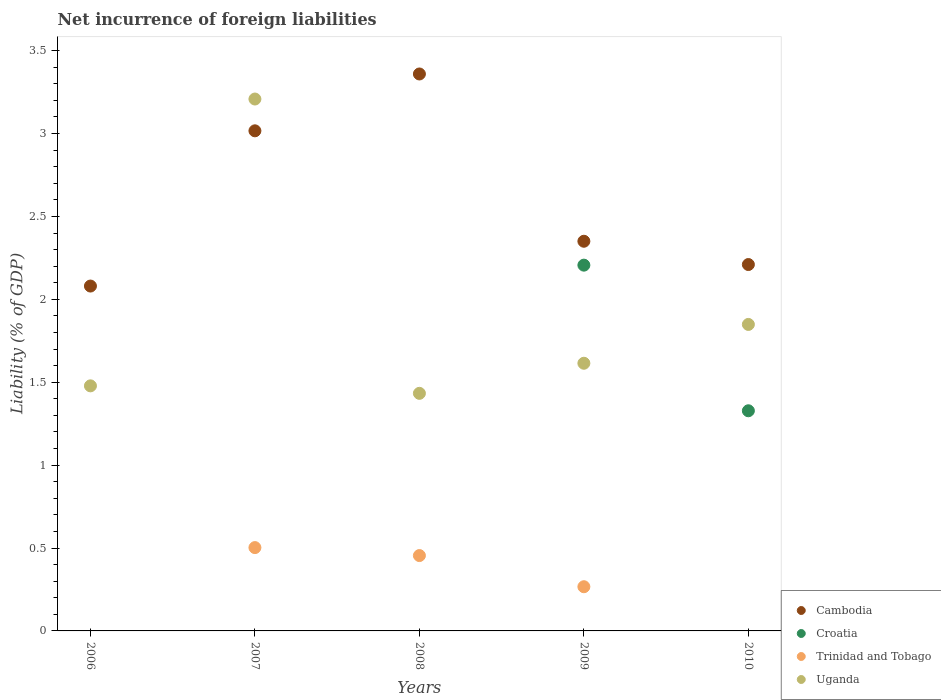What is the net incurrence of foreign liabilities in Cambodia in 2007?
Offer a terse response. 3.02. Across all years, what is the maximum net incurrence of foreign liabilities in Cambodia?
Provide a short and direct response. 3.36. In which year was the net incurrence of foreign liabilities in Trinidad and Tobago maximum?
Keep it short and to the point. 2007. What is the total net incurrence of foreign liabilities in Trinidad and Tobago in the graph?
Offer a terse response. 1.22. What is the difference between the net incurrence of foreign liabilities in Cambodia in 2006 and that in 2010?
Keep it short and to the point. -0.13. What is the difference between the net incurrence of foreign liabilities in Trinidad and Tobago in 2007 and the net incurrence of foreign liabilities in Uganda in 2009?
Offer a terse response. -1.11. What is the average net incurrence of foreign liabilities in Uganda per year?
Ensure brevity in your answer.  1.92. In the year 2009, what is the difference between the net incurrence of foreign liabilities in Croatia and net incurrence of foreign liabilities in Trinidad and Tobago?
Your answer should be compact. 1.94. In how many years, is the net incurrence of foreign liabilities in Cambodia greater than 1.1 %?
Offer a very short reply. 5. What is the ratio of the net incurrence of foreign liabilities in Uganda in 2007 to that in 2010?
Your response must be concise. 1.74. Is the net incurrence of foreign liabilities in Trinidad and Tobago in 2007 less than that in 2008?
Provide a succinct answer. No. What is the difference between the highest and the second highest net incurrence of foreign liabilities in Uganda?
Provide a succinct answer. 1.36. What is the difference between the highest and the lowest net incurrence of foreign liabilities in Croatia?
Give a very brief answer. 2.21. In how many years, is the net incurrence of foreign liabilities in Uganda greater than the average net incurrence of foreign liabilities in Uganda taken over all years?
Provide a short and direct response. 1. Is it the case that in every year, the sum of the net incurrence of foreign liabilities in Uganda and net incurrence of foreign liabilities in Trinidad and Tobago  is greater than the sum of net incurrence of foreign liabilities in Cambodia and net incurrence of foreign liabilities in Croatia?
Offer a terse response. Yes. Is the net incurrence of foreign liabilities in Trinidad and Tobago strictly less than the net incurrence of foreign liabilities in Uganda over the years?
Offer a terse response. Yes. Are the values on the major ticks of Y-axis written in scientific E-notation?
Provide a short and direct response. No. Does the graph contain any zero values?
Offer a very short reply. Yes. Does the graph contain grids?
Provide a short and direct response. No. How are the legend labels stacked?
Give a very brief answer. Vertical. What is the title of the graph?
Your response must be concise. Net incurrence of foreign liabilities. Does "Rwanda" appear as one of the legend labels in the graph?
Make the answer very short. No. What is the label or title of the X-axis?
Provide a short and direct response. Years. What is the label or title of the Y-axis?
Give a very brief answer. Liability (% of GDP). What is the Liability (% of GDP) in Cambodia in 2006?
Offer a very short reply. 2.08. What is the Liability (% of GDP) of Croatia in 2006?
Your answer should be compact. 0. What is the Liability (% of GDP) of Trinidad and Tobago in 2006?
Provide a succinct answer. 0. What is the Liability (% of GDP) of Uganda in 2006?
Ensure brevity in your answer.  1.48. What is the Liability (% of GDP) in Cambodia in 2007?
Your answer should be compact. 3.02. What is the Liability (% of GDP) in Croatia in 2007?
Make the answer very short. 0. What is the Liability (% of GDP) of Trinidad and Tobago in 2007?
Make the answer very short. 0.5. What is the Liability (% of GDP) in Uganda in 2007?
Provide a succinct answer. 3.21. What is the Liability (% of GDP) of Cambodia in 2008?
Your response must be concise. 3.36. What is the Liability (% of GDP) in Trinidad and Tobago in 2008?
Ensure brevity in your answer.  0.45. What is the Liability (% of GDP) of Uganda in 2008?
Ensure brevity in your answer.  1.43. What is the Liability (% of GDP) in Cambodia in 2009?
Your response must be concise. 2.35. What is the Liability (% of GDP) of Croatia in 2009?
Offer a very short reply. 2.21. What is the Liability (% of GDP) of Trinidad and Tobago in 2009?
Keep it short and to the point. 0.27. What is the Liability (% of GDP) of Uganda in 2009?
Ensure brevity in your answer.  1.61. What is the Liability (% of GDP) of Cambodia in 2010?
Your answer should be compact. 2.21. What is the Liability (% of GDP) of Croatia in 2010?
Your answer should be compact. 1.33. What is the Liability (% of GDP) in Uganda in 2010?
Your answer should be compact. 1.85. Across all years, what is the maximum Liability (% of GDP) of Cambodia?
Your answer should be very brief. 3.36. Across all years, what is the maximum Liability (% of GDP) in Croatia?
Your answer should be very brief. 2.21. Across all years, what is the maximum Liability (% of GDP) of Trinidad and Tobago?
Your answer should be compact. 0.5. Across all years, what is the maximum Liability (% of GDP) of Uganda?
Keep it short and to the point. 3.21. Across all years, what is the minimum Liability (% of GDP) of Cambodia?
Keep it short and to the point. 2.08. Across all years, what is the minimum Liability (% of GDP) of Uganda?
Provide a succinct answer. 1.43. What is the total Liability (% of GDP) in Cambodia in the graph?
Ensure brevity in your answer.  13.02. What is the total Liability (% of GDP) of Croatia in the graph?
Make the answer very short. 3.53. What is the total Liability (% of GDP) in Trinidad and Tobago in the graph?
Offer a very short reply. 1.22. What is the total Liability (% of GDP) in Uganda in the graph?
Offer a very short reply. 9.58. What is the difference between the Liability (% of GDP) of Cambodia in 2006 and that in 2007?
Keep it short and to the point. -0.94. What is the difference between the Liability (% of GDP) in Uganda in 2006 and that in 2007?
Give a very brief answer. -1.73. What is the difference between the Liability (% of GDP) in Cambodia in 2006 and that in 2008?
Ensure brevity in your answer.  -1.28. What is the difference between the Liability (% of GDP) in Uganda in 2006 and that in 2008?
Offer a terse response. 0.05. What is the difference between the Liability (% of GDP) in Cambodia in 2006 and that in 2009?
Your answer should be compact. -0.27. What is the difference between the Liability (% of GDP) in Uganda in 2006 and that in 2009?
Your answer should be very brief. -0.14. What is the difference between the Liability (% of GDP) of Cambodia in 2006 and that in 2010?
Your response must be concise. -0.13. What is the difference between the Liability (% of GDP) of Uganda in 2006 and that in 2010?
Offer a terse response. -0.37. What is the difference between the Liability (% of GDP) in Cambodia in 2007 and that in 2008?
Give a very brief answer. -0.34. What is the difference between the Liability (% of GDP) in Trinidad and Tobago in 2007 and that in 2008?
Your answer should be very brief. 0.05. What is the difference between the Liability (% of GDP) of Uganda in 2007 and that in 2008?
Offer a very short reply. 1.78. What is the difference between the Liability (% of GDP) in Cambodia in 2007 and that in 2009?
Give a very brief answer. 0.67. What is the difference between the Liability (% of GDP) in Trinidad and Tobago in 2007 and that in 2009?
Your answer should be compact. 0.24. What is the difference between the Liability (% of GDP) in Uganda in 2007 and that in 2009?
Keep it short and to the point. 1.59. What is the difference between the Liability (% of GDP) of Cambodia in 2007 and that in 2010?
Offer a terse response. 0.81. What is the difference between the Liability (% of GDP) of Uganda in 2007 and that in 2010?
Provide a short and direct response. 1.36. What is the difference between the Liability (% of GDP) in Trinidad and Tobago in 2008 and that in 2009?
Ensure brevity in your answer.  0.19. What is the difference between the Liability (% of GDP) of Uganda in 2008 and that in 2009?
Make the answer very short. -0.18. What is the difference between the Liability (% of GDP) in Cambodia in 2008 and that in 2010?
Offer a very short reply. 1.15. What is the difference between the Liability (% of GDP) in Uganda in 2008 and that in 2010?
Make the answer very short. -0.42. What is the difference between the Liability (% of GDP) in Cambodia in 2009 and that in 2010?
Your answer should be compact. 0.14. What is the difference between the Liability (% of GDP) in Croatia in 2009 and that in 2010?
Your answer should be very brief. 0.88. What is the difference between the Liability (% of GDP) in Uganda in 2009 and that in 2010?
Your answer should be very brief. -0.23. What is the difference between the Liability (% of GDP) of Cambodia in 2006 and the Liability (% of GDP) of Trinidad and Tobago in 2007?
Ensure brevity in your answer.  1.58. What is the difference between the Liability (% of GDP) of Cambodia in 2006 and the Liability (% of GDP) of Uganda in 2007?
Offer a very short reply. -1.13. What is the difference between the Liability (% of GDP) of Cambodia in 2006 and the Liability (% of GDP) of Trinidad and Tobago in 2008?
Give a very brief answer. 1.63. What is the difference between the Liability (% of GDP) in Cambodia in 2006 and the Liability (% of GDP) in Uganda in 2008?
Your answer should be compact. 0.65. What is the difference between the Liability (% of GDP) of Cambodia in 2006 and the Liability (% of GDP) of Croatia in 2009?
Make the answer very short. -0.13. What is the difference between the Liability (% of GDP) in Cambodia in 2006 and the Liability (% of GDP) in Trinidad and Tobago in 2009?
Provide a short and direct response. 1.81. What is the difference between the Liability (% of GDP) of Cambodia in 2006 and the Liability (% of GDP) of Uganda in 2009?
Make the answer very short. 0.47. What is the difference between the Liability (% of GDP) of Cambodia in 2006 and the Liability (% of GDP) of Croatia in 2010?
Offer a very short reply. 0.75. What is the difference between the Liability (% of GDP) in Cambodia in 2006 and the Liability (% of GDP) in Uganda in 2010?
Provide a short and direct response. 0.23. What is the difference between the Liability (% of GDP) of Cambodia in 2007 and the Liability (% of GDP) of Trinidad and Tobago in 2008?
Provide a short and direct response. 2.56. What is the difference between the Liability (% of GDP) of Cambodia in 2007 and the Liability (% of GDP) of Uganda in 2008?
Ensure brevity in your answer.  1.58. What is the difference between the Liability (% of GDP) of Trinidad and Tobago in 2007 and the Liability (% of GDP) of Uganda in 2008?
Make the answer very short. -0.93. What is the difference between the Liability (% of GDP) of Cambodia in 2007 and the Liability (% of GDP) of Croatia in 2009?
Your answer should be very brief. 0.81. What is the difference between the Liability (% of GDP) in Cambodia in 2007 and the Liability (% of GDP) in Trinidad and Tobago in 2009?
Your answer should be compact. 2.75. What is the difference between the Liability (% of GDP) in Cambodia in 2007 and the Liability (% of GDP) in Uganda in 2009?
Provide a succinct answer. 1.4. What is the difference between the Liability (% of GDP) in Trinidad and Tobago in 2007 and the Liability (% of GDP) in Uganda in 2009?
Your answer should be compact. -1.11. What is the difference between the Liability (% of GDP) of Cambodia in 2007 and the Liability (% of GDP) of Croatia in 2010?
Offer a terse response. 1.69. What is the difference between the Liability (% of GDP) in Cambodia in 2007 and the Liability (% of GDP) in Uganda in 2010?
Provide a short and direct response. 1.17. What is the difference between the Liability (% of GDP) in Trinidad and Tobago in 2007 and the Liability (% of GDP) in Uganda in 2010?
Your response must be concise. -1.35. What is the difference between the Liability (% of GDP) in Cambodia in 2008 and the Liability (% of GDP) in Croatia in 2009?
Keep it short and to the point. 1.15. What is the difference between the Liability (% of GDP) in Cambodia in 2008 and the Liability (% of GDP) in Trinidad and Tobago in 2009?
Offer a very short reply. 3.09. What is the difference between the Liability (% of GDP) in Cambodia in 2008 and the Liability (% of GDP) in Uganda in 2009?
Offer a very short reply. 1.74. What is the difference between the Liability (% of GDP) of Trinidad and Tobago in 2008 and the Liability (% of GDP) of Uganda in 2009?
Keep it short and to the point. -1.16. What is the difference between the Liability (% of GDP) of Cambodia in 2008 and the Liability (% of GDP) of Croatia in 2010?
Your response must be concise. 2.03. What is the difference between the Liability (% of GDP) of Cambodia in 2008 and the Liability (% of GDP) of Uganda in 2010?
Make the answer very short. 1.51. What is the difference between the Liability (% of GDP) of Trinidad and Tobago in 2008 and the Liability (% of GDP) of Uganda in 2010?
Your answer should be compact. -1.39. What is the difference between the Liability (% of GDP) of Cambodia in 2009 and the Liability (% of GDP) of Croatia in 2010?
Offer a terse response. 1.02. What is the difference between the Liability (% of GDP) of Cambodia in 2009 and the Liability (% of GDP) of Uganda in 2010?
Give a very brief answer. 0.5. What is the difference between the Liability (% of GDP) in Croatia in 2009 and the Liability (% of GDP) in Uganda in 2010?
Your answer should be compact. 0.36. What is the difference between the Liability (% of GDP) in Trinidad and Tobago in 2009 and the Liability (% of GDP) in Uganda in 2010?
Your answer should be compact. -1.58. What is the average Liability (% of GDP) of Cambodia per year?
Give a very brief answer. 2.6. What is the average Liability (% of GDP) in Croatia per year?
Ensure brevity in your answer.  0.71. What is the average Liability (% of GDP) in Trinidad and Tobago per year?
Offer a terse response. 0.24. What is the average Liability (% of GDP) of Uganda per year?
Your answer should be compact. 1.92. In the year 2006, what is the difference between the Liability (% of GDP) in Cambodia and Liability (% of GDP) in Uganda?
Make the answer very short. 0.6. In the year 2007, what is the difference between the Liability (% of GDP) in Cambodia and Liability (% of GDP) in Trinidad and Tobago?
Make the answer very short. 2.51. In the year 2007, what is the difference between the Liability (% of GDP) of Cambodia and Liability (% of GDP) of Uganda?
Make the answer very short. -0.19. In the year 2007, what is the difference between the Liability (% of GDP) of Trinidad and Tobago and Liability (% of GDP) of Uganda?
Give a very brief answer. -2.71. In the year 2008, what is the difference between the Liability (% of GDP) of Cambodia and Liability (% of GDP) of Trinidad and Tobago?
Keep it short and to the point. 2.9. In the year 2008, what is the difference between the Liability (% of GDP) in Cambodia and Liability (% of GDP) in Uganda?
Provide a short and direct response. 1.93. In the year 2008, what is the difference between the Liability (% of GDP) of Trinidad and Tobago and Liability (% of GDP) of Uganda?
Your answer should be very brief. -0.98. In the year 2009, what is the difference between the Liability (% of GDP) of Cambodia and Liability (% of GDP) of Croatia?
Offer a very short reply. 0.14. In the year 2009, what is the difference between the Liability (% of GDP) in Cambodia and Liability (% of GDP) in Trinidad and Tobago?
Ensure brevity in your answer.  2.08. In the year 2009, what is the difference between the Liability (% of GDP) of Cambodia and Liability (% of GDP) of Uganda?
Your response must be concise. 0.74. In the year 2009, what is the difference between the Liability (% of GDP) of Croatia and Liability (% of GDP) of Trinidad and Tobago?
Provide a short and direct response. 1.94. In the year 2009, what is the difference between the Liability (% of GDP) of Croatia and Liability (% of GDP) of Uganda?
Provide a short and direct response. 0.59. In the year 2009, what is the difference between the Liability (% of GDP) of Trinidad and Tobago and Liability (% of GDP) of Uganda?
Make the answer very short. -1.35. In the year 2010, what is the difference between the Liability (% of GDP) of Cambodia and Liability (% of GDP) of Croatia?
Give a very brief answer. 0.88. In the year 2010, what is the difference between the Liability (% of GDP) in Cambodia and Liability (% of GDP) in Uganda?
Give a very brief answer. 0.36. In the year 2010, what is the difference between the Liability (% of GDP) in Croatia and Liability (% of GDP) in Uganda?
Keep it short and to the point. -0.52. What is the ratio of the Liability (% of GDP) of Cambodia in 2006 to that in 2007?
Give a very brief answer. 0.69. What is the ratio of the Liability (% of GDP) in Uganda in 2006 to that in 2007?
Provide a succinct answer. 0.46. What is the ratio of the Liability (% of GDP) in Cambodia in 2006 to that in 2008?
Make the answer very short. 0.62. What is the ratio of the Liability (% of GDP) in Uganda in 2006 to that in 2008?
Ensure brevity in your answer.  1.03. What is the ratio of the Liability (% of GDP) in Cambodia in 2006 to that in 2009?
Your response must be concise. 0.89. What is the ratio of the Liability (% of GDP) in Uganda in 2006 to that in 2009?
Offer a terse response. 0.92. What is the ratio of the Liability (% of GDP) in Cambodia in 2006 to that in 2010?
Provide a short and direct response. 0.94. What is the ratio of the Liability (% of GDP) of Uganda in 2006 to that in 2010?
Make the answer very short. 0.8. What is the ratio of the Liability (% of GDP) in Cambodia in 2007 to that in 2008?
Offer a terse response. 0.9. What is the ratio of the Liability (% of GDP) in Trinidad and Tobago in 2007 to that in 2008?
Provide a short and direct response. 1.11. What is the ratio of the Liability (% of GDP) of Uganda in 2007 to that in 2008?
Give a very brief answer. 2.24. What is the ratio of the Liability (% of GDP) of Cambodia in 2007 to that in 2009?
Provide a succinct answer. 1.28. What is the ratio of the Liability (% of GDP) in Trinidad and Tobago in 2007 to that in 2009?
Ensure brevity in your answer.  1.89. What is the ratio of the Liability (% of GDP) in Uganda in 2007 to that in 2009?
Provide a short and direct response. 1.99. What is the ratio of the Liability (% of GDP) of Cambodia in 2007 to that in 2010?
Offer a very short reply. 1.36. What is the ratio of the Liability (% of GDP) in Uganda in 2007 to that in 2010?
Make the answer very short. 1.74. What is the ratio of the Liability (% of GDP) in Cambodia in 2008 to that in 2009?
Provide a short and direct response. 1.43. What is the ratio of the Liability (% of GDP) in Trinidad and Tobago in 2008 to that in 2009?
Offer a terse response. 1.71. What is the ratio of the Liability (% of GDP) of Uganda in 2008 to that in 2009?
Provide a succinct answer. 0.89. What is the ratio of the Liability (% of GDP) in Cambodia in 2008 to that in 2010?
Offer a terse response. 1.52. What is the ratio of the Liability (% of GDP) in Uganda in 2008 to that in 2010?
Your answer should be very brief. 0.78. What is the ratio of the Liability (% of GDP) in Cambodia in 2009 to that in 2010?
Provide a succinct answer. 1.06. What is the ratio of the Liability (% of GDP) in Croatia in 2009 to that in 2010?
Give a very brief answer. 1.66. What is the ratio of the Liability (% of GDP) of Uganda in 2009 to that in 2010?
Keep it short and to the point. 0.87. What is the difference between the highest and the second highest Liability (% of GDP) in Cambodia?
Offer a terse response. 0.34. What is the difference between the highest and the second highest Liability (% of GDP) in Trinidad and Tobago?
Provide a short and direct response. 0.05. What is the difference between the highest and the second highest Liability (% of GDP) of Uganda?
Your answer should be very brief. 1.36. What is the difference between the highest and the lowest Liability (% of GDP) of Cambodia?
Ensure brevity in your answer.  1.28. What is the difference between the highest and the lowest Liability (% of GDP) in Croatia?
Your answer should be very brief. 2.21. What is the difference between the highest and the lowest Liability (% of GDP) of Trinidad and Tobago?
Offer a terse response. 0.5. What is the difference between the highest and the lowest Liability (% of GDP) in Uganda?
Ensure brevity in your answer.  1.78. 